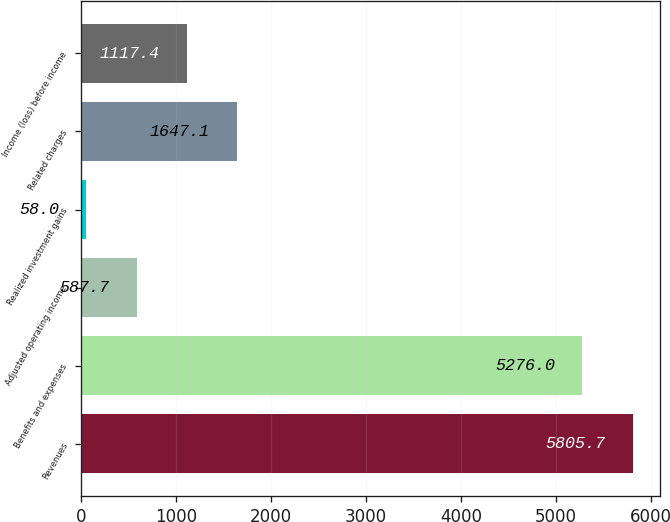Convert chart. <chart><loc_0><loc_0><loc_500><loc_500><bar_chart><fcel>Revenues<fcel>Benefits and expenses<fcel>Adjusted operating income<fcel>Realized investment gains<fcel>Related charges<fcel>Income (loss) before income<nl><fcel>5805.7<fcel>5276<fcel>587.7<fcel>58<fcel>1647.1<fcel>1117.4<nl></chart> 